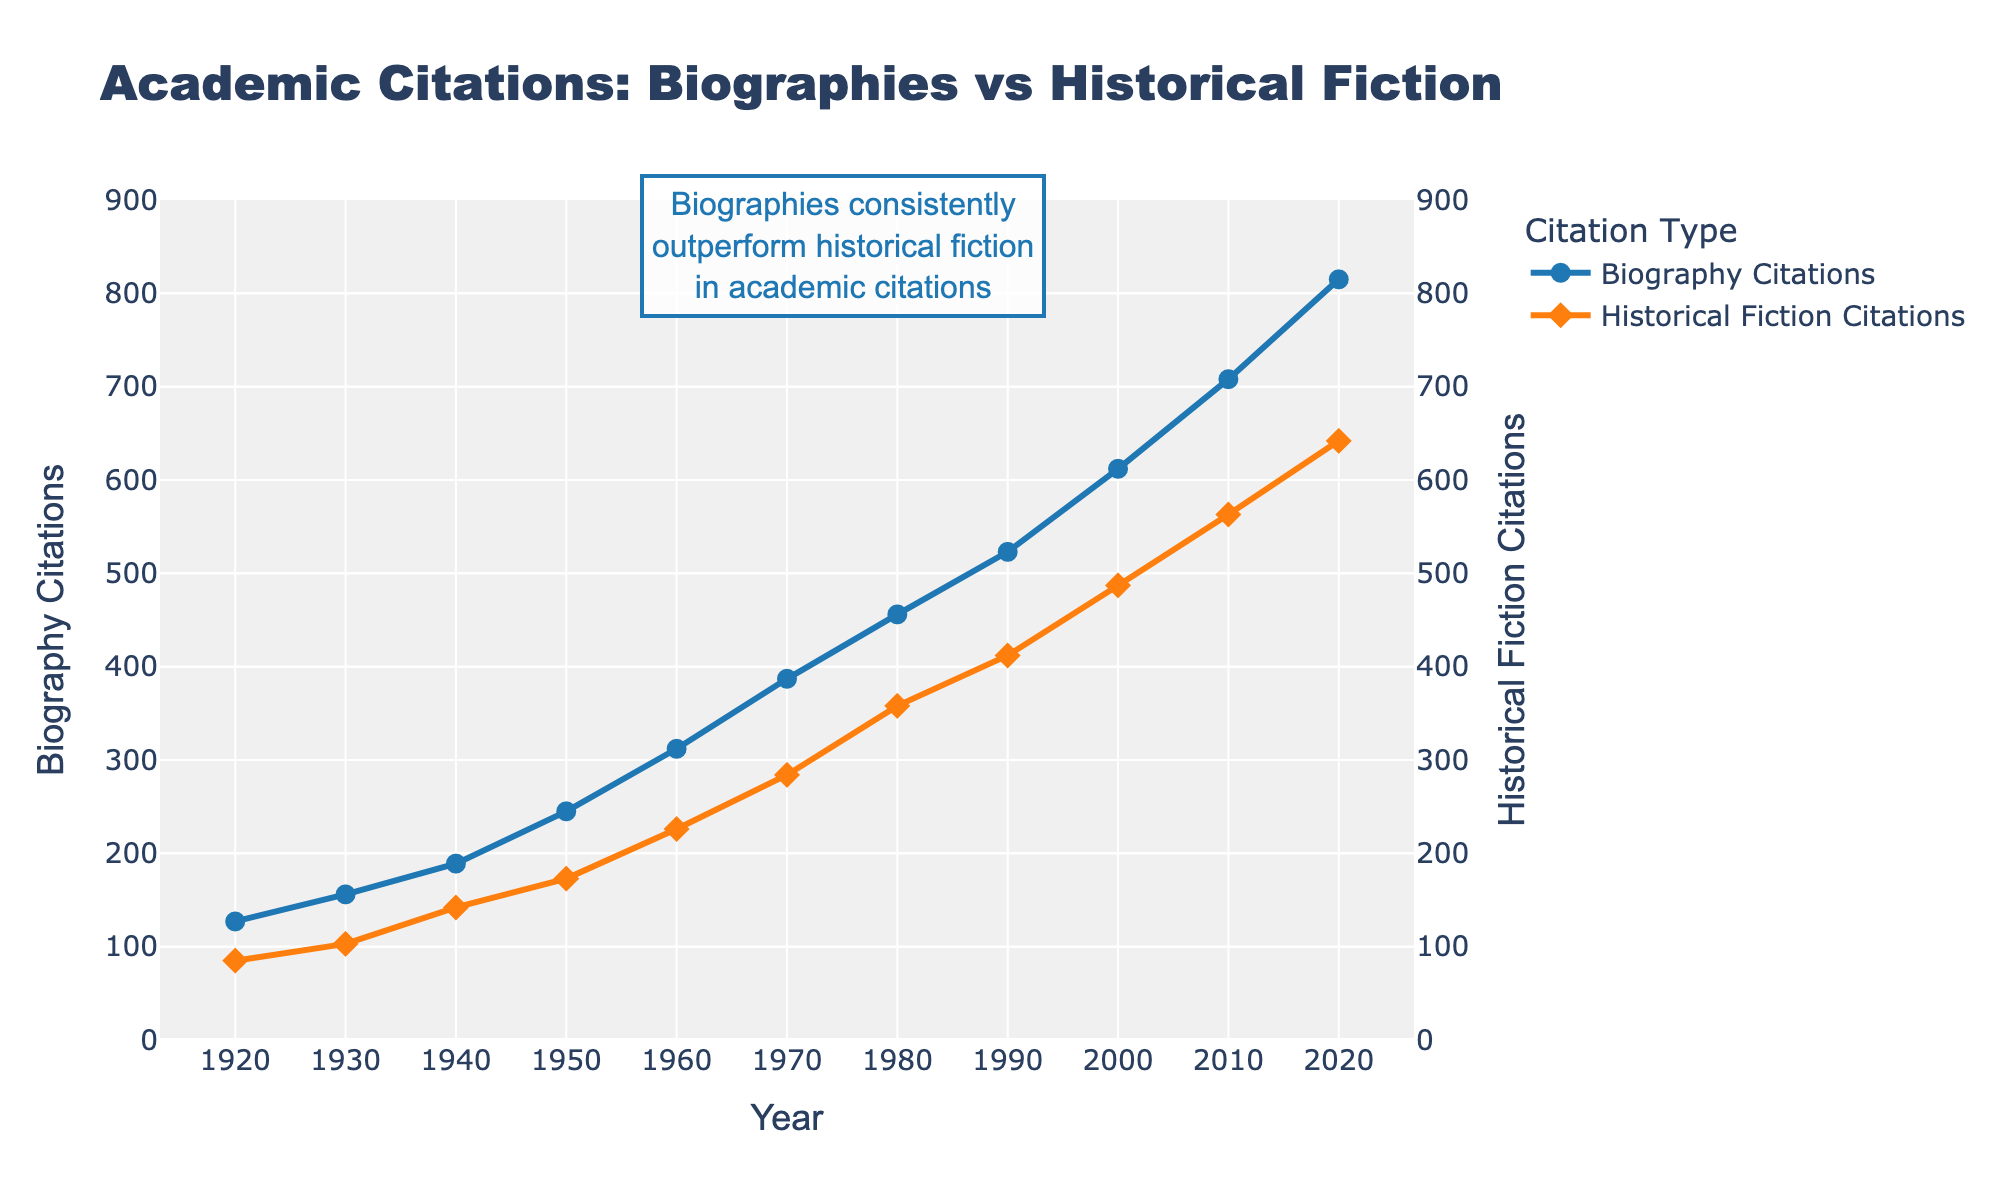what is the difference in Biography Citations between 2020 and 1920? To find the difference in Biography Citations between 2020 and 1920, subtract the value in 1920 from the value in 2020: 815 - 127 = 688.
Answer: 688 At which year did Biography Citations first exceed 300? To determine the year when Biography Citations first exceeded 300, locate the first point on the graph where the value passes 300. This occurs in 1960.
Answer: 1960 How do the citation trends for biographies and historical fiction compare overall? By examining the slopes of both lines, we can see that both citation types show an upward trend, but Biography Citations consistently rise at a higher rate and are always above Historical Fiction Citations.
Answer: Biography Citations increase at a higher rate and are always above Historical Fiction Citations What is the peak value of Historical Fiction Citations observed? The peak value of Historical Fiction Citations can be found at the highest point of the orange line on the chart, which is 642 in 2020.
Answer: 642 In which decade did Biography Citations experience the greatest increase? To find the decade with the greatest increase, calculate the difference in values for each decade. The differences are: 1930-1920 = 29, 1940-1930 = 33, 1950-1940 = 56, 1960-1950 = 67, 1970-1960 = 75, 1980-1970 = 69, 1990-1980 = 67, 2000-1990 = 89, 2010-2000 = 96, 2020-2010 = 107. The greatest increase is from 2010 to 2020.
Answer: 2010-2020 By how much did Historical Fiction Citations increase from 1980 to 2020? To find the increase in Historical Fiction Citations from 1980 to 2020, subtract the value in 1980 from the value in 2020: 642 - 358 = 284.
Answer: 284 Which citation type sees a greater increase from 1950 to 2010? Calculate the increase for each type: Biography Citations increased from 245 to 708 (708 - 245 = 463), Historical Fiction Citations increased from 173 to 563 (563 - 173 = 390). Biography Citations see a greater increase.
Answer: Biography Citations What are the citation counts for biographies and historical fiction in 1970? Locate the values on the graph for 1970. Biography Citations are 387, and Historical Fiction Citations are 284.
Answer: Biography: 387, Historical Fiction: 284 Which citation type has the steeper line slope between 2000 and 2020? To compare the slopes, calculate the change per year: For Biography Citations: (815 - 612)/20 = 10.15, for Historical Fiction Citations: (642 - 487)/20 = 7.75. Biography Citations have the steeper slope.
Answer: Biography Citations 